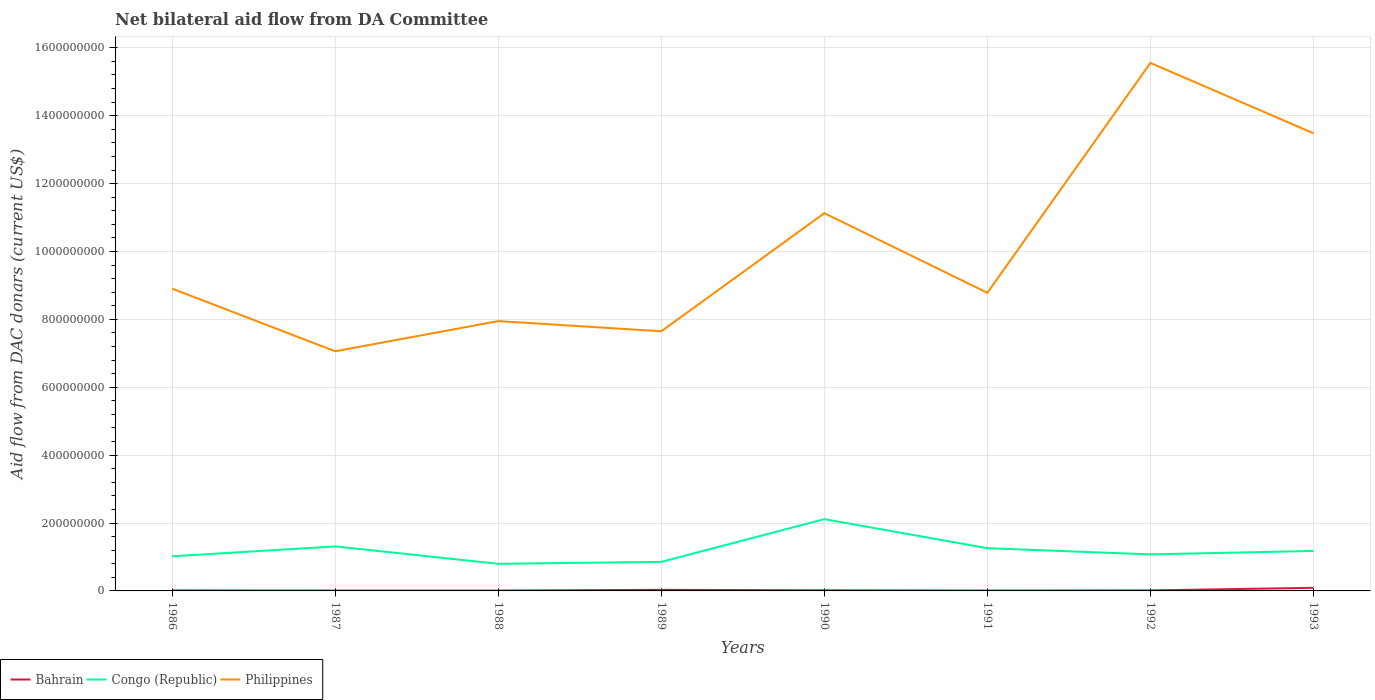Does the line corresponding to Congo (Republic) intersect with the line corresponding to Philippines?
Your answer should be very brief. No. Across all years, what is the maximum aid flow in in Philippines?
Your answer should be very brief. 7.06e+08. What is the total aid flow in in Philippines in the graph?
Your answer should be compact. -4.58e+08. What is the difference between the highest and the second highest aid flow in in Philippines?
Make the answer very short. 8.49e+08. Are the values on the major ticks of Y-axis written in scientific E-notation?
Make the answer very short. No. Does the graph contain any zero values?
Keep it short and to the point. No. Does the graph contain grids?
Make the answer very short. Yes. How are the legend labels stacked?
Make the answer very short. Horizontal. What is the title of the graph?
Your answer should be compact. Net bilateral aid flow from DA Committee. What is the label or title of the X-axis?
Give a very brief answer. Years. What is the label or title of the Y-axis?
Your response must be concise. Aid flow from DAC donars (current US$). What is the Aid flow from DAC donars (current US$) of Bahrain in 1986?
Offer a terse response. 1.48e+06. What is the Aid flow from DAC donars (current US$) of Congo (Republic) in 1986?
Give a very brief answer. 1.02e+08. What is the Aid flow from DAC donars (current US$) of Philippines in 1986?
Keep it short and to the point. 8.90e+08. What is the Aid flow from DAC donars (current US$) in Bahrain in 1987?
Give a very brief answer. 1.06e+06. What is the Aid flow from DAC donars (current US$) of Congo (Republic) in 1987?
Give a very brief answer. 1.31e+08. What is the Aid flow from DAC donars (current US$) of Philippines in 1987?
Keep it short and to the point. 7.06e+08. What is the Aid flow from DAC donars (current US$) of Bahrain in 1988?
Provide a succinct answer. 1.07e+06. What is the Aid flow from DAC donars (current US$) in Congo (Republic) in 1988?
Offer a terse response. 7.99e+07. What is the Aid flow from DAC donars (current US$) in Philippines in 1988?
Your answer should be compact. 7.95e+08. What is the Aid flow from DAC donars (current US$) of Bahrain in 1989?
Provide a succinct answer. 3.24e+06. What is the Aid flow from DAC donars (current US$) of Congo (Republic) in 1989?
Offer a very short reply. 8.56e+07. What is the Aid flow from DAC donars (current US$) in Philippines in 1989?
Your answer should be compact. 7.65e+08. What is the Aid flow from DAC donars (current US$) in Bahrain in 1990?
Make the answer very short. 1.86e+06. What is the Aid flow from DAC donars (current US$) of Congo (Republic) in 1990?
Give a very brief answer. 2.11e+08. What is the Aid flow from DAC donars (current US$) in Philippines in 1990?
Offer a very short reply. 1.11e+09. What is the Aid flow from DAC donars (current US$) of Bahrain in 1991?
Keep it short and to the point. 1.12e+06. What is the Aid flow from DAC donars (current US$) in Congo (Republic) in 1991?
Ensure brevity in your answer.  1.26e+08. What is the Aid flow from DAC donars (current US$) in Philippines in 1991?
Offer a very short reply. 8.78e+08. What is the Aid flow from DAC donars (current US$) in Bahrain in 1992?
Provide a short and direct response. 1.52e+06. What is the Aid flow from DAC donars (current US$) in Congo (Republic) in 1992?
Ensure brevity in your answer.  1.08e+08. What is the Aid flow from DAC donars (current US$) in Philippines in 1992?
Make the answer very short. 1.56e+09. What is the Aid flow from DAC donars (current US$) in Bahrain in 1993?
Offer a terse response. 9.14e+06. What is the Aid flow from DAC donars (current US$) in Congo (Republic) in 1993?
Offer a terse response. 1.18e+08. What is the Aid flow from DAC donars (current US$) in Philippines in 1993?
Provide a short and direct response. 1.35e+09. Across all years, what is the maximum Aid flow from DAC donars (current US$) in Bahrain?
Keep it short and to the point. 9.14e+06. Across all years, what is the maximum Aid flow from DAC donars (current US$) in Congo (Republic)?
Provide a short and direct response. 2.11e+08. Across all years, what is the maximum Aid flow from DAC donars (current US$) of Philippines?
Provide a short and direct response. 1.56e+09. Across all years, what is the minimum Aid flow from DAC donars (current US$) in Bahrain?
Offer a terse response. 1.06e+06. Across all years, what is the minimum Aid flow from DAC donars (current US$) in Congo (Republic)?
Offer a very short reply. 7.99e+07. Across all years, what is the minimum Aid flow from DAC donars (current US$) in Philippines?
Ensure brevity in your answer.  7.06e+08. What is the total Aid flow from DAC donars (current US$) in Bahrain in the graph?
Keep it short and to the point. 2.05e+07. What is the total Aid flow from DAC donars (current US$) in Congo (Republic) in the graph?
Provide a short and direct response. 9.61e+08. What is the total Aid flow from DAC donars (current US$) of Philippines in the graph?
Keep it short and to the point. 8.05e+09. What is the difference between the Aid flow from DAC donars (current US$) of Congo (Republic) in 1986 and that in 1987?
Your answer should be very brief. -2.92e+07. What is the difference between the Aid flow from DAC donars (current US$) of Philippines in 1986 and that in 1987?
Your response must be concise. 1.84e+08. What is the difference between the Aid flow from DAC donars (current US$) of Congo (Republic) in 1986 and that in 1988?
Keep it short and to the point. 2.20e+07. What is the difference between the Aid flow from DAC donars (current US$) of Philippines in 1986 and that in 1988?
Your answer should be compact. 9.55e+07. What is the difference between the Aid flow from DAC donars (current US$) in Bahrain in 1986 and that in 1989?
Provide a short and direct response. -1.76e+06. What is the difference between the Aid flow from DAC donars (current US$) in Congo (Republic) in 1986 and that in 1989?
Make the answer very short. 1.64e+07. What is the difference between the Aid flow from DAC donars (current US$) of Philippines in 1986 and that in 1989?
Your answer should be very brief. 1.25e+08. What is the difference between the Aid flow from DAC donars (current US$) in Bahrain in 1986 and that in 1990?
Keep it short and to the point. -3.80e+05. What is the difference between the Aid flow from DAC donars (current US$) of Congo (Republic) in 1986 and that in 1990?
Your response must be concise. -1.09e+08. What is the difference between the Aid flow from DAC donars (current US$) of Philippines in 1986 and that in 1990?
Keep it short and to the point. -2.22e+08. What is the difference between the Aid flow from DAC donars (current US$) of Congo (Republic) in 1986 and that in 1991?
Offer a very short reply. -2.40e+07. What is the difference between the Aid flow from DAC donars (current US$) of Philippines in 1986 and that in 1991?
Give a very brief answer. 1.20e+07. What is the difference between the Aid flow from DAC donars (current US$) in Congo (Republic) in 1986 and that in 1992?
Offer a terse response. -5.65e+06. What is the difference between the Aid flow from DAC donars (current US$) of Philippines in 1986 and that in 1992?
Offer a terse response. -6.65e+08. What is the difference between the Aid flow from DAC donars (current US$) in Bahrain in 1986 and that in 1993?
Offer a very short reply. -7.66e+06. What is the difference between the Aid flow from DAC donars (current US$) in Congo (Republic) in 1986 and that in 1993?
Your answer should be compact. -1.59e+07. What is the difference between the Aid flow from DAC donars (current US$) in Philippines in 1986 and that in 1993?
Provide a short and direct response. -4.58e+08. What is the difference between the Aid flow from DAC donars (current US$) in Bahrain in 1987 and that in 1988?
Your answer should be very brief. -10000. What is the difference between the Aid flow from DAC donars (current US$) in Congo (Republic) in 1987 and that in 1988?
Provide a short and direct response. 5.13e+07. What is the difference between the Aid flow from DAC donars (current US$) in Philippines in 1987 and that in 1988?
Your answer should be compact. -8.89e+07. What is the difference between the Aid flow from DAC donars (current US$) in Bahrain in 1987 and that in 1989?
Offer a terse response. -2.18e+06. What is the difference between the Aid flow from DAC donars (current US$) of Congo (Republic) in 1987 and that in 1989?
Provide a short and direct response. 4.56e+07. What is the difference between the Aid flow from DAC donars (current US$) of Philippines in 1987 and that in 1989?
Keep it short and to the point. -5.89e+07. What is the difference between the Aid flow from DAC donars (current US$) in Bahrain in 1987 and that in 1990?
Your answer should be very brief. -8.00e+05. What is the difference between the Aid flow from DAC donars (current US$) of Congo (Republic) in 1987 and that in 1990?
Offer a terse response. -8.02e+07. What is the difference between the Aid flow from DAC donars (current US$) in Philippines in 1987 and that in 1990?
Offer a terse response. -4.07e+08. What is the difference between the Aid flow from DAC donars (current US$) of Congo (Republic) in 1987 and that in 1991?
Make the answer very short. 5.26e+06. What is the difference between the Aid flow from DAC donars (current US$) in Philippines in 1987 and that in 1991?
Your answer should be very brief. -1.72e+08. What is the difference between the Aid flow from DAC donars (current US$) in Bahrain in 1987 and that in 1992?
Your response must be concise. -4.60e+05. What is the difference between the Aid flow from DAC donars (current US$) in Congo (Republic) in 1987 and that in 1992?
Offer a very short reply. 2.36e+07. What is the difference between the Aid flow from DAC donars (current US$) of Philippines in 1987 and that in 1992?
Give a very brief answer. -8.49e+08. What is the difference between the Aid flow from DAC donars (current US$) in Bahrain in 1987 and that in 1993?
Provide a short and direct response. -8.08e+06. What is the difference between the Aid flow from DAC donars (current US$) of Congo (Republic) in 1987 and that in 1993?
Your response must be concise. 1.33e+07. What is the difference between the Aid flow from DAC donars (current US$) in Philippines in 1987 and that in 1993?
Make the answer very short. -6.42e+08. What is the difference between the Aid flow from DAC donars (current US$) in Bahrain in 1988 and that in 1989?
Give a very brief answer. -2.17e+06. What is the difference between the Aid flow from DAC donars (current US$) of Congo (Republic) in 1988 and that in 1989?
Your answer should be compact. -5.66e+06. What is the difference between the Aid flow from DAC donars (current US$) in Philippines in 1988 and that in 1989?
Your response must be concise. 3.00e+07. What is the difference between the Aid flow from DAC donars (current US$) in Bahrain in 1988 and that in 1990?
Ensure brevity in your answer.  -7.90e+05. What is the difference between the Aid flow from DAC donars (current US$) in Congo (Republic) in 1988 and that in 1990?
Make the answer very short. -1.32e+08. What is the difference between the Aid flow from DAC donars (current US$) in Philippines in 1988 and that in 1990?
Your answer should be very brief. -3.18e+08. What is the difference between the Aid flow from DAC donars (current US$) in Bahrain in 1988 and that in 1991?
Provide a short and direct response. -5.00e+04. What is the difference between the Aid flow from DAC donars (current US$) of Congo (Republic) in 1988 and that in 1991?
Provide a short and direct response. -4.60e+07. What is the difference between the Aid flow from DAC donars (current US$) of Philippines in 1988 and that in 1991?
Ensure brevity in your answer.  -8.34e+07. What is the difference between the Aid flow from DAC donars (current US$) of Bahrain in 1988 and that in 1992?
Provide a short and direct response. -4.50e+05. What is the difference between the Aid flow from DAC donars (current US$) in Congo (Republic) in 1988 and that in 1992?
Ensure brevity in your answer.  -2.77e+07. What is the difference between the Aid flow from DAC donars (current US$) in Philippines in 1988 and that in 1992?
Give a very brief answer. -7.60e+08. What is the difference between the Aid flow from DAC donars (current US$) of Bahrain in 1988 and that in 1993?
Your response must be concise. -8.07e+06. What is the difference between the Aid flow from DAC donars (current US$) in Congo (Republic) in 1988 and that in 1993?
Your answer should be very brief. -3.80e+07. What is the difference between the Aid flow from DAC donars (current US$) in Philippines in 1988 and that in 1993?
Make the answer very short. -5.53e+08. What is the difference between the Aid flow from DAC donars (current US$) of Bahrain in 1989 and that in 1990?
Give a very brief answer. 1.38e+06. What is the difference between the Aid flow from DAC donars (current US$) of Congo (Republic) in 1989 and that in 1990?
Provide a short and direct response. -1.26e+08. What is the difference between the Aid flow from DAC donars (current US$) in Philippines in 1989 and that in 1990?
Make the answer very short. -3.48e+08. What is the difference between the Aid flow from DAC donars (current US$) of Bahrain in 1989 and that in 1991?
Ensure brevity in your answer.  2.12e+06. What is the difference between the Aid flow from DAC donars (current US$) of Congo (Republic) in 1989 and that in 1991?
Make the answer very short. -4.03e+07. What is the difference between the Aid flow from DAC donars (current US$) of Philippines in 1989 and that in 1991?
Offer a terse response. -1.13e+08. What is the difference between the Aid flow from DAC donars (current US$) in Bahrain in 1989 and that in 1992?
Keep it short and to the point. 1.72e+06. What is the difference between the Aid flow from DAC donars (current US$) of Congo (Republic) in 1989 and that in 1992?
Your answer should be very brief. -2.20e+07. What is the difference between the Aid flow from DAC donars (current US$) in Philippines in 1989 and that in 1992?
Your response must be concise. -7.90e+08. What is the difference between the Aid flow from DAC donars (current US$) of Bahrain in 1989 and that in 1993?
Give a very brief answer. -5.90e+06. What is the difference between the Aid flow from DAC donars (current US$) in Congo (Republic) in 1989 and that in 1993?
Keep it short and to the point. -3.23e+07. What is the difference between the Aid flow from DAC donars (current US$) in Philippines in 1989 and that in 1993?
Offer a very short reply. -5.83e+08. What is the difference between the Aid flow from DAC donars (current US$) of Bahrain in 1990 and that in 1991?
Your answer should be compact. 7.40e+05. What is the difference between the Aid flow from DAC donars (current US$) of Congo (Republic) in 1990 and that in 1991?
Offer a very short reply. 8.55e+07. What is the difference between the Aid flow from DAC donars (current US$) of Philippines in 1990 and that in 1991?
Ensure brevity in your answer.  2.34e+08. What is the difference between the Aid flow from DAC donars (current US$) in Congo (Republic) in 1990 and that in 1992?
Provide a short and direct response. 1.04e+08. What is the difference between the Aid flow from DAC donars (current US$) in Philippines in 1990 and that in 1992?
Provide a succinct answer. -4.43e+08. What is the difference between the Aid flow from DAC donars (current US$) of Bahrain in 1990 and that in 1993?
Your answer should be compact. -7.28e+06. What is the difference between the Aid flow from DAC donars (current US$) in Congo (Republic) in 1990 and that in 1993?
Your response must be concise. 9.35e+07. What is the difference between the Aid flow from DAC donars (current US$) in Philippines in 1990 and that in 1993?
Your answer should be very brief. -2.35e+08. What is the difference between the Aid flow from DAC donars (current US$) in Bahrain in 1991 and that in 1992?
Ensure brevity in your answer.  -4.00e+05. What is the difference between the Aid flow from DAC donars (current US$) of Congo (Republic) in 1991 and that in 1992?
Keep it short and to the point. 1.83e+07. What is the difference between the Aid flow from DAC donars (current US$) of Philippines in 1991 and that in 1992?
Ensure brevity in your answer.  -6.77e+08. What is the difference between the Aid flow from DAC donars (current US$) in Bahrain in 1991 and that in 1993?
Your response must be concise. -8.02e+06. What is the difference between the Aid flow from DAC donars (current US$) of Congo (Republic) in 1991 and that in 1993?
Provide a succinct answer. 8.04e+06. What is the difference between the Aid flow from DAC donars (current US$) of Philippines in 1991 and that in 1993?
Give a very brief answer. -4.70e+08. What is the difference between the Aid flow from DAC donars (current US$) of Bahrain in 1992 and that in 1993?
Ensure brevity in your answer.  -7.62e+06. What is the difference between the Aid flow from DAC donars (current US$) in Congo (Republic) in 1992 and that in 1993?
Your answer should be very brief. -1.03e+07. What is the difference between the Aid flow from DAC donars (current US$) of Philippines in 1992 and that in 1993?
Your response must be concise. 2.07e+08. What is the difference between the Aid flow from DAC donars (current US$) in Bahrain in 1986 and the Aid flow from DAC donars (current US$) in Congo (Republic) in 1987?
Your response must be concise. -1.30e+08. What is the difference between the Aid flow from DAC donars (current US$) in Bahrain in 1986 and the Aid flow from DAC donars (current US$) in Philippines in 1987?
Keep it short and to the point. -7.05e+08. What is the difference between the Aid flow from DAC donars (current US$) in Congo (Republic) in 1986 and the Aid flow from DAC donars (current US$) in Philippines in 1987?
Your answer should be very brief. -6.04e+08. What is the difference between the Aid flow from DAC donars (current US$) in Bahrain in 1986 and the Aid flow from DAC donars (current US$) in Congo (Republic) in 1988?
Your answer should be compact. -7.84e+07. What is the difference between the Aid flow from DAC donars (current US$) in Bahrain in 1986 and the Aid flow from DAC donars (current US$) in Philippines in 1988?
Offer a terse response. -7.93e+08. What is the difference between the Aid flow from DAC donars (current US$) of Congo (Republic) in 1986 and the Aid flow from DAC donars (current US$) of Philippines in 1988?
Provide a short and direct response. -6.93e+08. What is the difference between the Aid flow from DAC donars (current US$) of Bahrain in 1986 and the Aid flow from DAC donars (current US$) of Congo (Republic) in 1989?
Keep it short and to the point. -8.41e+07. What is the difference between the Aid flow from DAC donars (current US$) of Bahrain in 1986 and the Aid flow from DAC donars (current US$) of Philippines in 1989?
Give a very brief answer. -7.63e+08. What is the difference between the Aid flow from DAC donars (current US$) in Congo (Republic) in 1986 and the Aid flow from DAC donars (current US$) in Philippines in 1989?
Provide a short and direct response. -6.63e+08. What is the difference between the Aid flow from DAC donars (current US$) of Bahrain in 1986 and the Aid flow from DAC donars (current US$) of Congo (Republic) in 1990?
Provide a short and direct response. -2.10e+08. What is the difference between the Aid flow from DAC donars (current US$) of Bahrain in 1986 and the Aid flow from DAC donars (current US$) of Philippines in 1990?
Make the answer very short. -1.11e+09. What is the difference between the Aid flow from DAC donars (current US$) in Congo (Republic) in 1986 and the Aid flow from DAC donars (current US$) in Philippines in 1990?
Make the answer very short. -1.01e+09. What is the difference between the Aid flow from DAC donars (current US$) in Bahrain in 1986 and the Aid flow from DAC donars (current US$) in Congo (Republic) in 1991?
Offer a terse response. -1.24e+08. What is the difference between the Aid flow from DAC donars (current US$) of Bahrain in 1986 and the Aid flow from DAC donars (current US$) of Philippines in 1991?
Give a very brief answer. -8.77e+08. What is the difference between the Aid flow from DAC donars (current US$) in Congo (Republic) in 1986 and the Aid flow from DAC donars (current US$) in Philippines in 1991?
Offer a very short reply. -7.76e+08. What is the difference between the Aid flow from DAC donars (current US$) in Bahrain in 1986 and the Aid flow from DAC donars (current US$) in Congo (Republic) in 1992?
Keep it short and to the point. -1.06e+08. What is the difference between the Aid flow from DAC donars (current US$) in Bahrain in 1986 and the Aid flow from DAC donars (current US$) in Philippines in 1992?
Give a very brief answer. -1.55e+09. What is the difference between the Aid flow from DAC donars (current US$) in Congo (Republic) in 1986 and the Aid flow from DAC donars (current US$) in Philippines in 1992?
Keep it short and to the point. -1.45e+09. What is the difference between the Aid flow from DAC donars (current US$) in Bahrain in 1986 and the Aid flow from DAC donars (current US$) in Congo (Republic) in 1993?
Your response must be concise. -1.16e+08. What is the difference between the Aid flow from DAC donars (current US$) of Bahrain in 1986 and the Aid flow from DAC donars (current US$) of Philippines in 1993?
Provide a short and direct response. -1.35e+09. What is the difference between the Aid flow from DAC donars (current US$) in Congo (Republic) in 1986 and the Aid flow from DAC donars (current US$) in Philippines in 1993?
Your answer should be compact. -1.25e+09. What is the difference between the Aid flow from DAC donars (current US$) in Bahrain in 1987 and the Aid flow from DAC donars (current US$) in Congo (Republic) in 1988?
Offer a very short reply. -7.88e+07. What is the difference between the Aid flow from DAC donars (current US$) of Bahrain in 1987 and the Aid flow from DAC donars (current US$) of Philippines in 1988?
Give a very brief answer. -7.94e+08. What is the difference between the Aid flow from DAC donars (current US$) of Congo (Republic) in 1987 and the Aid flow from DAC donars (current US$) of Philippines in 1988?
Offer a terse response. -6.64e+08. What is the difference between the Aid flow from DAC donars (current US$) in Bahrain in 1987 and the Aid flow from DAC donars (current US$) in Congo (Republic) in 1989?
Your answer should be very brief. -8.45e+07. What is the difference between the Aid flow from DAC donars (current US$) in Bahrain in 1987 and the Aid flow from DAC donars (current US$) in Philippines in 1989?
Your answer should be compact. -7.64e+08. What is the difference between the Aid flow from DAC donars (current US$) in Congo (Republic) in 1987 and the Aid flow from DAC donars (current US$) in Philippines in 1989?
Your response must be concise. -6.34e+08. What is the difference between the Aid flow from DAC donars (current US$) of Bahrain in 1987 and the Aid flow from DAC donars (current US$) of Congo (Republic) in 1990?
Keep it short and to the point. -2.10e+08. What is the difference between the Aid flow from DAC donars (current US$) in Bahrain in 1987 and the Aid flow from DAC donars (current US$) in Philippines in 1990?
Offer a terse response. -1.11e+09. What is the difference between the Aid flow from DAC donars (current US$) in Congo (Republic) in 1987 and the Aid flow from DAC donars (current US$) in Philippines in 1990?
Ensure brevity in your answer.  -9.82e+08. What is the difference between the Aid flow from DAC donars (current US$) in Bahrain in 1987 and the Aid flow from DAC donars (current US$) in Congo (Republic) in 1991?
Give a very brief answer. -1.25e+08. What is the difference between the Aid flow from DAC donars (current US$) in Bahrain in 1987 and the Aid flow from DAC donars (current US$) in Philippines in 1991?
Ensure brevity in your answer.  -8.77e+08. What is the difference between the Aid flow from DAC donars (current US$) in Congo (Republic) in 1987 and the Aid flow from DAC donars (current US$) in Philippines in 1991?
Provide a succinct answer. -7.47e+08. What is the difference between the Aid flow from DAC donars (current US$) of Bahrain in 1987 and the Aid flow from DAC donars (current US$) of Congo (Republic) in 1992?
Provide a succinct answer. -1.07e+08. What is the difference between the Aid flow from DAC donars (current US$) of Bahrain in 1987 and the Aid flow from DAC donars (current US$) of Philippines in 1992?
Provide a succinct answer. -1.55e+09. What is the difference between the Aid flow from DAC donars (current US$) of Congo (Republic) in 1987 and the Aid flow from DAC donars (current US$) of Philippines in 1992?
Your response must be concise. -1.42e+09. What is the difference between the Aid flow from DAC donars (current US$) of Bahrain in 1987 and the Aid flow from DAC donars (current US$) of Congo (Republic) in 1993?
Your answer should be very brief. -1.17e+08. What is the difference between the Aid flow from DAC donars (current US$) of Bahrain in 1987 and the Aid flow from DAC donars (current US$) of Philippines in 1993?
Ensure brevity in your answer.  -1.35e+09. What is the difference between the Aid flow from DAC donars (current US$) in Congo (Republic) in 1987 and the Aid flow from DAC donars (current US$) in Philippines in 1993?
Ensure brevity in your answer.  -1.22e+09. What is the difference between the Aid flow from DAC donars (current US$) in Bahrain in 1988 and the Aid flow from DAC donars (current US$) in Congo (Republic) in 1989?
Provide a succinct answer. -8.45e+07. What is the difference between the Aid flow from DAC donars (current US$) of Bahrain in 1988 and the Aid flow from DAC donars (current US$) of Philippines in 1989?
Keep it short and to the point. -7.64e+08. What is the difference between the Aid flow from DAC donars (current US$) of Congo (Republic) in 1988 and the Aid flow from DAC donars (current US$) of Philippines in 1989?
Give a very brief answer. -6.85e+08. What is the difference between the Aid flow from DAC donars (current US$) of Bahrain in 1988 and the Aid flow from DAC donars (current US$) of Congo (Republic) in 1990?
Your answer should be very brief. -2.10e+08. What is the difference between the Aid flow from DAC donars (current US$) of Bahrain in 1988 and the Aid flow from DAC donars (current US$) of Philippines in 1990?
Make the answer very short. -1.11e+09. What is the difference between the Aid flow from DAC donars (current US$) of Congo (Republic) in 1988 and the Aid flow from DAC donars (current US$) of Philippines in 1990?
Provide a short and direct response. -1.03e+09. What is the difference between the Aid flow from DAC donars (current US$) in Bahrain in 1988 and the Aid flow from DAC donars (current US$) in Congo (Republic) in 1991?
Your answer should be compact. -1.25e+08. What is the difference between the Aid flow from DAC donars (current US$) in Bahrain in 1988 and the Aid flow from DAC donars (current US$) in Philippines in 1991?
Your answer should be very brief. -8.77e+08. What is the difference between the Aid flow from DAC donars (current US$) in Congo (Republic) in 1988 and the Aid flow from DAC donars (current US$) in Philippines in 1991?
Offer a very short reply. -7.98e+08. What is the difference between the Aid flow from DAC donars (current US$) in Bahrain in 1988 and the Aid flow from DAC donars (current US$) in Congo (Republic) in 1992?
Ensure brevity in your answer.  -1.07e+08. What is the difference between the Aid flow from DAC donars (current US$) in Bahrain in 1988 and the Aid flow from DAC donars (current US$) in Philippines in 1992?
Your answer should be very brief. -1.55e+09. What is the difference between the Aid flow from DAC donars (current US$) of Congo (Republic) in 1988 and the Aid flow from DAC donars (current US$) of Philippines in 1992?
Your response must be concise. -1.48e+09. What is the difference between the Aid flow from DAC donars (current US$) in Bahrain in 1988 and the Aid flow from DAC donars (current US$) in Congo (Republic) in 1993?
Keep it short and to the point. -1.17e+08. What is the difference between the Aid flow from DAC donars (current US$) in Bahrain in 1988 and the Aid flow from DAC donars (current US$) in Philippines in 1993?
Your answer should be compact. -1.35e+09. What is the difference between the Aid flow from DAC donars (current US$) of Congo (Republic) in 1988 and the Aid flow from DAC donars (current US$) of Philippines in 1993?
Offer a very short reply. -1.27e+09. What is the difference between the Aid flow from DAC donars (current US$) in Bahrain in 1989 and the Aid flow from DAC donars (current US$) in Congo (Republic) in 1990?
Your response must be concise. -2.08e+08. What is the difference between the Aid flow from DAC donars (current US$) in Bahrain in 1989 and the Aid flow from DAC donars (current US$) in Philippines in 1990?
Your response must be concise. -1.11e+09. What is the difference between the Aid flow from DAC donars (current US$) of Congo (Republic) in 1989 and the Aid flow from DAC donars (current US$) of Philippines in 1990?
Offer a terse response. -1.03e+09. What is the difference between the Aid flow from DAC donars (current US$) of Bahrain in 1989 and the Aid flow from DAC donars (current US$) of Congo (Republic) in 1991?
Provide a short and direct response. -1.23e+08. What is the difference between the Aid flow from DAC donars (current US$) of Bahrain in 1989 and the Aid flow from DAC donars (current US$) of Philippines in 1991?
Make the answer very short. -8.75e+08. What is the difference between the Aid flow from DAC donars (current US$) of Congo (Republic) in 1989 and the Aid flow from DAC donars (current US$) of Philippines in 1991?
Your response must be concise. -7.93e+08. What is the difference between the Aid flow from DAC donars (current US$) in Bahrain in 1989 and the Aid flow from DAC donars (current US$) in Congo (Republic) in 1992?
Your answer should be compact. -1.04e+08. What is the difference between the Aid flow from DAC donars (current US$) of Bahrain in 1989 and the Aid flow from DAC donars (current US$) of Philippines in 1992?
Provide a succinct answer. -1.55e+09. What is the difference between the Aid flow from DAC donars (current US$) of Congo (Republic) in 1989 and the Aid flow from DAC donars (current US$) of Philippines in 1992?
Offer a very short reply. -1.47e+09. What is the difference between the Aid flow from DAC donars (current US$) of Bahrain in 1989 and the Aid flow from DAC donars (current US$) of Congo (Republic) in 1993?
Ensure brevity in your answer.  -1.15e+08. What is the difference between the Aid flow from DAC donars (current US$) of Bahrain in 1989 and the Aid flow from DAC donars (current US$) of Philippines in 1993?
Your response must be concise. -1.35e+09. What is the difference between the Aid flow from DAC donars (current US$) in Congo (Republic) in 1989 and the Aid flow from DAC donars (current US$) in Philippines in 1993?
Make the answer very short. -1.26e+09. What is the difference between the Aid flow from DAC donars (current US$) of Bahrain in 1990 and the Aid flow from DAC donars (current US$) of Congo (Republic) in 1991?
Provide a succinct answer. -1.24e+08. What is the difference between the Aid flow from DAC donars (current US$) in Bahrain in 1990 and the Aid flow from DAC donars (current US$) in Philippines in 1991?
Offer a terse response. -8.76e+08. What is the difference between the Aid flow from DAC donars (current US$) in Congo (Republic) in 1990 and the Aid flow from DAC donars (current US$) in Philippines in 1991?
Your response must be concise. -6.67e+08. What is the difference between the Aid flow from DAC donars (current US$) in Bahrain in 1990 and the Aid flow from DAC donars (current US$) in Congo (Republic) in 1992?
Provide a short and direct response. -1.06e+08. What is the difference between the Aid flow from DAC donars (current US$) in Bahrain in 1990 and the Aid flow from DAC donars (current US$) in Philippines in 1992?
Keep it short and to the point. -1.55e+09. What is the difference between the Aid flow from DAC donars (current US$) in Congo (Republic) in 1990 and the Aid flow from DAC donars (current US$) in Philippines in 1992?
Your answer should be compact. -1.34e+09. What is the difference between the Aid flow from DAC donars (current US$) of Bahrain in 1990 and the Aid flow from DAC donars (current US$) of Congo (Republic) in 1993?
Your answer should be very brief. -1.16e+08. What is the difference between the Aid flow from DAC donars (current US$) in Bahrain in 1990 and the Aid flow from DAC donars (current US$) in Philippines in 1993?
Offer a very short reply. -1.35e+09. What is the difference between the Aid flow from DAC donars (current US$) in Congo (Republic) in 1990 and the Aid flow from DAC donars (current US$) in Philippines in 1993?
Offer a very short reply. -1.14e+09. What is the difference between the Aid flow from DAC donars (current US$) of Bahrain in 1991 and the Aid flow from DAC donars (current US$) of Congo (Republic) in 1992?
Offer a very short reply. -1.06e+08. What is the difference between the Aid flow from DAC donars (current US$) in Bahrain in 1991 and the Aid flow from DAC donars (current US$) in Philippines in 1992?
Keep it short and to the point. -1.55e+09. What is the difference between the Aid flow from DAC donars (current US$) of Congo (Republic) in 1991 and the Aid flow from DAC donars (current US$) of Philippines in 1992?
Ensure brevity in your answer.  -1.43e+09. What is the difference between the Aid flow from DAC donars (current US$) in Bahrain in 1991 and the Aid flow from DAC donars (current US$) in Congo (Republic) in 1993?
Provide a succinct answer. -1.17e+08. What is the difference between the Aid flow from DAC donars (current US$) in Bahrain in 1991 and the Aid flow from DAC donars (current US$) in Philippines in 1993?
Offer a terse response. -1.35e+09. What is the difference between the Aid flow from DAC donars (current US$) of Congo (Republic) in 1991 and the Aid flow from DAC donars (current US$) of Philippines in 1993?
Your answer should be very brief. -1.22e+09. What is the difference between the Aid flow from DAC donars (current US$) of Bahrain in 1992 and the Aid flow from DAC donars (current US$) of Congo (Republic) in 1993?
Give a very brief answer. -1.16e+08. What is the difference between the Aid flow from DAC donars (current US$) in Bahrain in 1992 and the Aid flow from DAC donars (current US$) in Philippines in 1993?
Provide a succinct answer. -1.35e+09. What is the difference between the Aid flow from DAC donars (current US$) in Congo (Republic) in 1992 and the Aid flow from DAC donars (current US$) in Philippines in 1993?
Ensure brevity in your answer.  -1.24e+09. What is the average Aid flow from DAC donars (current US$) of Bahrain per year?
Your answer should be very brief. 2.56e+06. What is the average Aid flow from DAC donars (current US$) in Congo (Republic) per year?
Provide a succinct answer. 1.20e+08. What is the average Aid flow from DAC donars (current US$) of Philippines per year?
Ensure brevity in your answer.  1.01e+09. In the year 1986, what is the difference between the Aid flow from DAC donars (current US$) of Bahrain and Aid flow from DAC donars (current US$) of Congo (Republic)?
Your response must be concise. -1.00e+08. In the year 1986, what is the difference between the Aid flow from DAC donars (current US$) in Bahrain and Aid flow from DAC donars (current US$) in Philippines?
Your answer should be very brief. -8.89e+08. In the year 1986, what is the difference between the Aid flow from DAC donars (current US$) of Congo (Republic) and Aid flow from DAC donars (current US$) of Philippines?
Your response must be concise. -7.88e+08. In the year 1987, what is the difference between the Aid flow from DAC donars (current US$) of Bahrain and Aid flow from DAC donars (current US$) of Congo (Republic)?
Give a very brief answer. -1.30e+08. In the year 1987, what is the difference between the Aid flow from DAC donars (current US$) of Bahrain and Aid flow from DAC donars (current US$) of Philippines?
Provide a succinct answer. -7.05e+08. In the year 1987, what is the difference between the Aid flow from DAC donars (current US$) in Congo (Republic) and Aid flow from DAC donars (current US$) in Philippines?
Give a very brief answer. -5.75e+08. In the year 1988, what is the difference between the Aid flow from DAC donars (current US$) of Bahrain and Aid flow from DAC donars (current US$) of Congo (Republic)?
Provide a short and direct response. -7.88e+07. In the year 1988, what is the difference between the Aid flow from DAC donars (current US$) of Bahrain and Aid flow from DAC donars (current US$) of Philippines?
Your answer should be very brief. -7.94e+08. In the year 1988, what is the difference between the Aid flow from DAC donars (current US$) in Congo (Republic) and Aid flow from DAC donars (current US$) in Philippines?
Provide a succinct answer. -7.15e+08. In the year 1989, what is the difference between the Aid flow from DAC donars (current US$) in Bahrain and Aid flow from DAC donars (current US$) in Congo (Republic)?
Your answer should be very brief. -8.23e+07. In the year 1989, what is the difference between the Aid flow from DAC donars (current US$) in Bahrain and Aid flow from DAC donars (current US$) in Philippines?
Give a very brief answer. -7.62e+08. In the year 1989, what is the difference between the Aid flow from DAC donars (current US$) of Congo (Republic) and Aid flow from DAC donars (current US$) of Philippines?
Your answer should be compact. -6.79e+08. In the year 1990, what is the difference between the Aid flow from DAC donars (current US$) in Bahrain and Aid flow from DAC donars (current US$) in Congo (Republic)?
Keep it short and to the point. -2.10e+08. In the year 1990, what is the difference between the Aid flow from DAC donars (current US$) of Bahrain and Aid flow from DAC donars (current US$) of Philippines?
Provide a short and direct response. -1.11e+09. In the year 1990, what is the difference between the Aid flow from DAC donars (current US$) of Congo (Republic) and Aid flow from DAC donars (current US$) of Philippines?
Ensure brevity in your answer.  -9.01e+08. In the year 1991, what is the difference between the Aid flow from DAC donars (current US$) in Bahrain and Aid flow from DAC donars (current US$) in Congo (Republic)?
Give a very brief answer. -1.25e+08. In the year 1991, what is the difference between the Aid flow from DAC donars (current US$) in Bahrain and Aid flow from DAC donars (current US$) in Philippines?
Keep it short and to the point. -8.77e+08. In the year 1991, what is the difference between the Aid flow from DAC donars (current US$) in Congo (Republic) and Aid flow from DAC donars (current US$) in Philippines?
Give a very brief answer. -7.52e+08. In the year 1992, what is the difference between the Aid flow from DAC donars (current US$) of Bahrain and Aid flow from DAC donars (current US$) of Congo (Republic)?
Provide a short and direct response. -1.06e+08. In the year 1992, what is the difference between the Aid flow from DAC donars (current US$) in Bahrain and Aid flow from DAC donars (current US$) in Philippines?
Ensure brevity in your answer.  -1.55e+09. In the year 1992, what is the difference between the Aid flow from DAC donars (current US$) of Congo (Republic) and Aid flow from DAC donars (current US$) of Philippines?
Give a very brief answer. -1.45e+09. In the year 1993, what is the difference between the Aid flow from DAC donars (current US$) in Bahrain and Aid flow from DAC donars (current US$) in Congo (Republic)?
Make the answer very short. -1.09e+08. In the year 1993, what is the difference between the Aid flow from DAC donars (current US$) of Bahrain and Aid flow from DAC donars (current US$) of Philippines?
Your answer should be very brief. -1.34e+09. In the year 1993, what is the difference between the Aid flow from DAC donars (current US$) in Congo (Republic) and Aid flow from DAC donars (current US$) in Philippines?
Offer a terse response. -1.23e+09. What is the ratio of the Aid flow from DAC donars (current US$) of Bahrain in 1986 to that in 1987?
Make the answer very short. 1.4. What is the ratio of the Aid flow from DAC donars (current US$) in Congo (Republic) in 1986 to that in 1987?
Your answer should be compact. 0.78. What is the ratio of the Aid flow from DAC donars (current US$) of Philippines in 1986 to that in 1987?
Make the answer very short. 1.26. What is the ratio of the Aid flow from DAC donars (current US$) of Bahrain in 1986 to that in 1988?
Keep it short and to the point. 1.38. What is the ratio of the Aid flow from DAC donars (current US$) in Congo (Republic) in 1986 to that in 1988?
Ensure brevity in your answer.  1.28. What is the ratio of the Aid flow from DAC donars (current US$) in Philippines in 1986 to that in 1988?
Your answer should be very brief. 1.12. What is the ratio of the Aid flow from DAC donars (current US$) of Bahrain in 1986 to that in 1989?
Keep it short and to the point. 0.46. What is the ratio of the Aid flow from DAC donars (current US$) in Congo (Republic) in 1986 to that in 1989?
Provide a succinct answer. 1.19. What is the ratio of the Aid flow from DAC donars (current US$) in Philippines in 1986 to that in 1989?
Keep it short and to the point. 1.16. What is the ratio of the Aid flow from DAC donars (current US$) in Bahrain in 1986 to that in 1990?
Ensure brevity in your answer.  0.8. What is the ratio of the Aid flow from DAC donars (current US$) of Congo (Republic) in 1986 to that in 1990?
Give a very brief answer. 0.48. What is the ratio of the Aid flow from DAC donars (current US$) of Philippines in 1986 to that in 1990?
Keep it short and to the point. 0.8. What is the ratio of the Aid flow from DAC donars (current US$) of Bahrain in 1986 to that in 1991?
Your answer should be very brief. 1.32. What is the ratio of the Aid flow from DAC donars (current US$) in Congo (Republic) in 1986 to that in 1991?
Ensure brevity in your answer.  0.81. What is the ratio of the Aid flow from DAC donars (current US$) in Philippines in 1986 to that in 1991?
Your answer should be very brief. 1.01. What is the ratio of the Aid flow from DAC donars (current US$) of Bahrain in 1986 to that in 1992?
Offer a very short reply. 0.97. What is the ratio of the Aid flow from DAC donars (current US$) of Congo (Republic) in 1986 to that in 1992?
Ensure brevity in your answer.  0.95. What is the ratio of the Aid flow from DAC donars (current US$) of Philippines in 1986 to that in 1992?
Your answer should be compact. 0.57. What is the ratio of the Aid flow from DAC donars (current US$) in Bahrain in 1986 to that in 1993?
Give a very brief answer. 0.16. What is the ratio of the Aid flow from DAC donars (current US$) in Congo (Republic) in 1986 to that in 1993?
Ensure brevity in your answer.  0.86. What is the ratio of the Aid flow from DAC donars (current US$) in Philippines in 1986 to that in 1993?
Make the answer very short. 0.66. What is the ratio of the Aid flow from DAC donars (current US$) of Congo (Republic) in 1987 to that in 1988?
Provide a short and direct response. 1.64. What is the ratio of the Aid flow from DAC donars (current US$) in Philippines in 1987 to that in 1988?
Ensure brevity in your answer.  0.89. What is the ratio of the Aid flow from DAC donars (current US$) in Bahrain in 1987 to that in 1989?
Make the answer very short. 0.33. What is the ratio of the Aid flow from DAC donars (current US$) in Congo (Republic) in 1987 to that in 1989?
Keep it short and to the point. 1.53. What is the ratio of the Aid flow from DAC donars (current US$) of Philippines in 1987 to that in 1989?
Make the answer very short. 0.92. What is the ratio of the Aid flow from DAC donars (current US$) in Bahrain in 1987 to that in 1990?
Make the answer very short. 0.57. What is the ratio of the Aid flow from DAC donars (current US$) in Congo (Republic) in 1987 to that in 1990?
Ensure brevity in your answer.  0.62. What is the ratio of the Aid flow from DAC donars (current US$) in Philippines in 1987 to that in 1990?
Provide a succinct answer. 0.63. What is the ratio of the Aid flow from DAC donars (current US$) of Bahrain in 1987 to that in 1991?
Provide a succinct answer. 0.95. What is the ratio of the Aid flow from DAC donars (current US$) of Congo (Republic) in 1987 to that in 1991?
Give a very brief answer. 1.04. What is the ratio of the Aid flow from DAC donars (current US$) of Philippines in 1987 to that in 1991?
Your answer should be very brief. 0.8. What is the ratio of the Aid flow from DAC donars (current US$) in Bahrain in 1987 to that in 1992?
Keep it short and to the point. 0.7. What is the ratio of the Aid flow from DAC donars (current US$) in Congo (Republic) in 1987 to that in 1992?
Provide a short and direct response. 1.22. What is the ratio of the Aid flow from DAC donars (current US$) of Philippines in 1987 to that in 1992?
Your response must be concise. 0.45. What is the ratio of the Aid flow from DAC donars (current US$) of Bahrain in 1987 to that in 1993?
Your response must be concise. 0.12. What is the ratio of the Aid flow from DAC donars (current US$) of Congo (Republic) in 1987 to that in 1993?
Offer a very short reply. 1.11. What is the ratio of the Aid flow from DAC donars (current US$) of Philippines in 1987 to that in 1993?
Offer a terse response. 0.52. What is the ratio of the Aid flow from DAC donars (current US$) of Bahrain in 1988 to that in 1989?
Give a very brief answer. 0.33. What is the ratio of the Aid flow from DAC donars (current US$) in Congo (Republic) in 1988 to that in 1989?
Give a very brief answer. 0.93. What is the ratio of the Aid flow from DAC donars (current US$) of Philippines in 1988 to that in 1989?
Offer a terse response. 1.04. What is the ratio of the Aid flow from DAC donars (current US$) in Bahrain in 1988 to that in 1990?
Ensure brevity in your answer.  0.58. What is the ratio of the Aid flow from DAC donars (current US$) in Congo (Republic) in 1988 to that in 1990?
Make the answer very short. 0.38. What is the ratio of the Aid flow from DAC donars (current US$) of Philippines in 1988 to that in 1990?
Provide a short and direct response. 0.71. What is the ratio of the Aid flow from DAC donars (current US$) in Bahrain in 1988 to that in 1991?
Offer a terse response. 0.96. What is the ratio of the Aid flow from DAC donars (current US$) of Congo (Republic) in 1988 to that in 1991?
Keep it short and to the point. 0.63. What is the ratio of the Aid flow from DAC donars (current US$) of Philippines in 1988 to that in 1991?
Your response must be concise. 0.91. What is the ratio of the Aid flow from DAC donars (current US$) of Bahrain in 1988 to that in 1992?
Your answer should be compact. 0.7. What is the ratio of the Aid flow from DAC donars (current US$) of Congo (Republic) in 1988 to that in 1992?
Your answer should be compact. 0.74. What is the ratio of the Aid flow from DAC donars (current US$) of Philippines in 1988 to that in 1992?
Give a very brief answer. 0.51. What is the ratio of the Aid flow from DAC donars (current US$) of Bahrain in 1988 to that in 1993?
Your answer should be compact. 0.12. What is the ratio of the Aid flow from DAC donars (current US$) of Congo (Republic) in 1988 to that in 1993?
Provide a succinct answer. 0.68. What is the ratio of the Aid flow from DAC donars (current US$) of Philippines in 1988 to that in 1993?
Your answer should be compact. 0.59. What is the ratio of the Aid flow from DAC donars (current US$) in Bahrain in 1989 to that in 1990?
Ensure brevity in your answer.  1.74. What is the ratio of the Aid flow from DAC donars (current US$) in Congo (Republic) in 1989 to that in 1990?
Ensure brevity in your answer.  0.4. What is the ratio of the Aid flow from DAC donars (current US$) of Philippines in 1989 to that in 1990?
Ensure brevity in your answer.  0.69. What is the ratio of the Aid flow from DAC donars (current US$) in Bahrain in 1989 to that in 1991?
Provide a succinct answer. 2.89. What is the ratio of the Aid flow from DAC donars (current US$) in Congo (Republic) in 1989 to that in 1991?
Keep it short and to the point. 0.68. What is the ratio of the Aid flow from DAC donars (current US$) of Philippines in 1989 to that in 1991?
Make the answer very short. 0.87. What is the ratio of the Aid flow from DAC donars (current US$) of Bahrain in 1989 to that in 1992?
Your answer should be very brief. 2.13. What is the ratio of the Aid flow from DAC donars (current US$) of Congo (Republic) in 1989 to that in 1992?
Ensure brevity in your answer.  0.8. What is the ratio of the Aid flow from DAC donars (current US$) in Philippines in 1989 to that in 1992?
Your response must be concise. 0.49. What is the ratio of the Aid flow from DAC donars (current US$) of Bahrain in 1989 to that in 1993?
Give a very brief answer. 0.35. What is the ratio of the Aid flow from DAC donars (current US$) of Congo (Republic) in 1989 to that in 1993?
Make the answer very short. 0.73. What is the ratio of the Aid flow from DAC donars (current US$) in Philippines in 1989 to that in 1993?
Your response must be concise. 0.57. What is the ratio of the Aid flow from DAC donars (current US$) of Bahrain in 1990 to that in 1991?
Offer a terse response. 1.66. What is the ratio of the Aid flow from DAC donars (current US$) of Congo (Republic) in 1990 to that in 1991?
Provide a short and direct response. 1.68. What is the ratio of the Aid flow from DAC donars (current US$) of Philippines in 1990 to that in 1991?
Provide a succinct answer. 1.27. What is the ratio of the Aid flow from DAC donars (current US$) of Bahrain in 1990 to that in 1992?
Your answer should be compact. 1.22. What is the ratio of the Aid flow from DAC donars (current US$) of Congo (Republic) in 1990 to that in 1992?
Provide a succinct answer. 1.96. What is the ratio of the Aid flow from DAC donars (current US$) of Philippines in 1990 to that in 1992?
Offer a very short reply. 0.72. What is the ratio of the Aid flow from DAC donars (current US$) of Bahrain in 1990 to that in 1993?
Give a very brief answer. 0.2. What is the ratio of the Aid flow from DAC donars (current US$) in Congo (Republic) in 1990 to that in 1993?
Your answer should be very brief. 1.79. What is the ratio of the Aid flow from DAC donars (current US$) of Philippines in 1990 to that in 1993?
Provide a succinct answer. 0.83. What is the ratio of the Aid flow from DAC donars (current US$) in Bahrain in 1991 to that in 1992?
Give a very brief answer. 0.74. What is the ratio of the Aid flow from DAC donars (current US$) in Congo (Republic) in 1991 to that in 1992?
Give a very brief answer. 1.17. What is the ratio of the Aid flow from DAC donars (current US$) in Philippines in 1991 to that in 1992?
Give a very brief answer. 0.56. What is the ratio of the Aid flow from DAC donars (current US$) of Bahrain in 1991 to that in 1993?
Keep it short and to the point. 0.12. What is the ratio of the Aid flow from DAC donars (current US$) in Congo (Republic) in 1991 to that in 1993?
Make the answer very short. 1.07. What is the ratio of the Aid flow from DAC donars (current US$) in Philippines in 1991 to that in 1993?
Give a very brief answer. 0.65. What is the ratio of the Aid flow from DAC donars (current US$) of Bahrain in 1992 to that in 1993?
Your answer should be compact. 0.17. What is the ratio of the Aid flow from DAC donars (current US$) in Congo (Republic) in 1992 to that in 1993?
Provide a short and direct response. 0.91. What is the ratio of the Aid flow from DAC donars (current US$) in Philippines in 1992 to that in 1993?
Make the answer very short. 1.15. What is the difference between the highest and the second highest Aid flow from DAC donars (current US$) of Bahrain?
Your answer should be very brief. 5.90e+06. What is the difference between the highest and the second highest Aid flow from DAC donars (current US$) in Congo (Republic)?
Your answer should be compact. 8.02e+07. What is the difference between the highest and the second highest Aid flow from DAC donars (current US$) in Philippines?
Offer a very short reply. 2.07e+08. What is the difference between the highest and the lowest Aid flow from DAC donars (current US$) in Bahrain?
Make the answer very short. 8.08e+06. What is the difference between the highest and the lowest Aid flow from DAC donars (current US$) in Congo (Republic)?
Ensure brevity in your answer.  1.32e+08. What is the difference between the highest and the lowest Aid flow from DAC donars (current US$) of Philippines?
Offer a very short reply. 8.49e+08. 